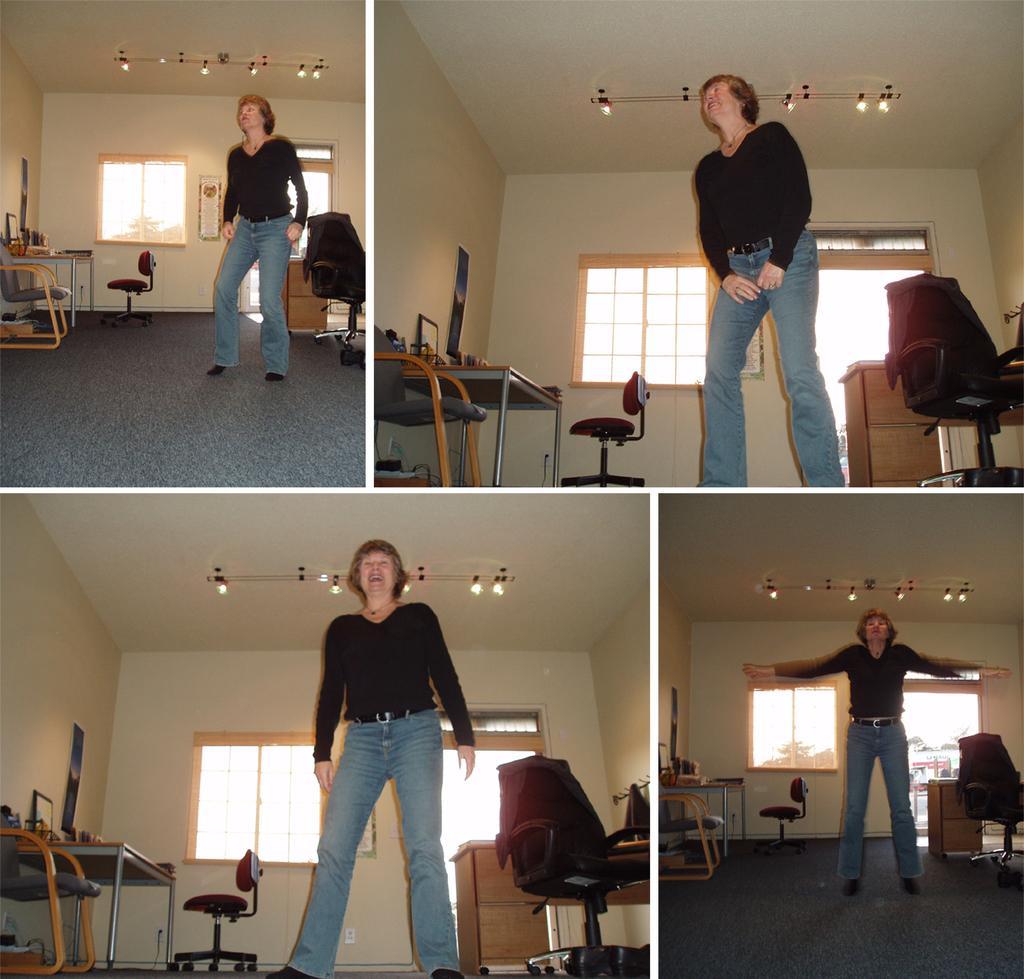In one or two sentences, can you explain what this image depicts? In this image there are four women who is standing on the top there is a ceiling and on the right side of the image there is a wall and on the left side of the image there is a wall and in the middle there is a wall and windows are there. Beside that window there is a door on the top of the right corner and on the bottom of the right corner there is a door and on the top of the left corner there is a window and beside that window there is a door and on the bottom of the left corner there is a window and beside the window there is one door and chairs, tables, photo frames are there. 